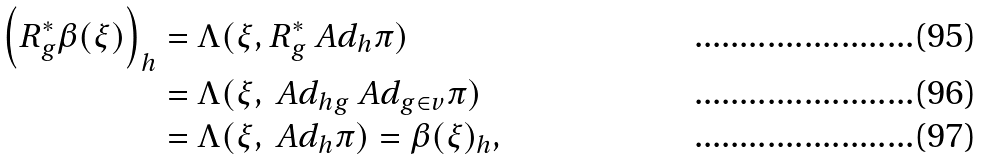Convert formula to latex. <formula><loc_0><loc_0><loc_500><loc_500>\left ( R _ { g } ^ { * } \beta ( \xi ) \right ) _ { h } & = \Lambda ( \xi , R _ { g } ^ { * } \ A d _ { h } \pi ) \\ & = \Lambda ( \xi , \ A d _ { h g } \ A d _ { g \in v } \pi ) \\ & = \Lambda ( \xi , \ A d _ { h } \pi ) = \beta ( \xi ) _ { h } ,</formula> 